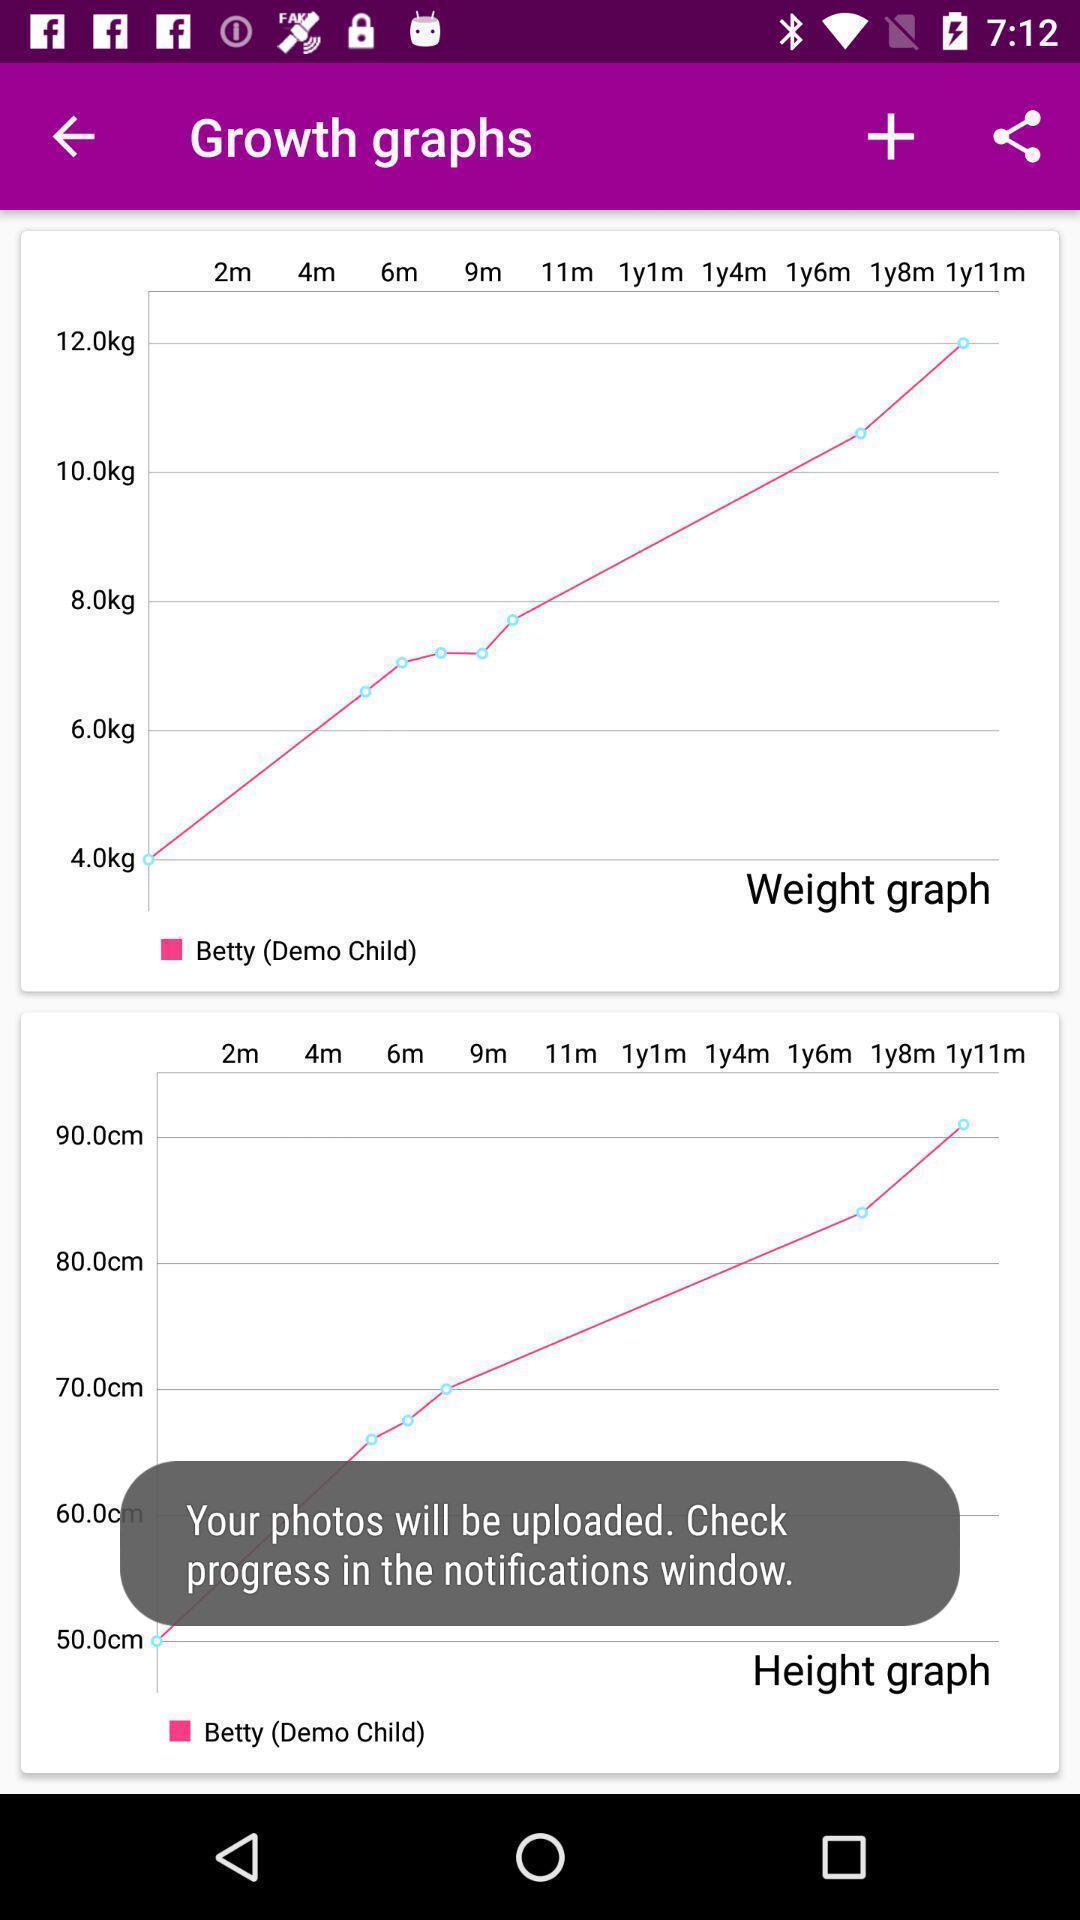Tell me about the visual elements in this screen capture. Screen shows graph details in a health app. 